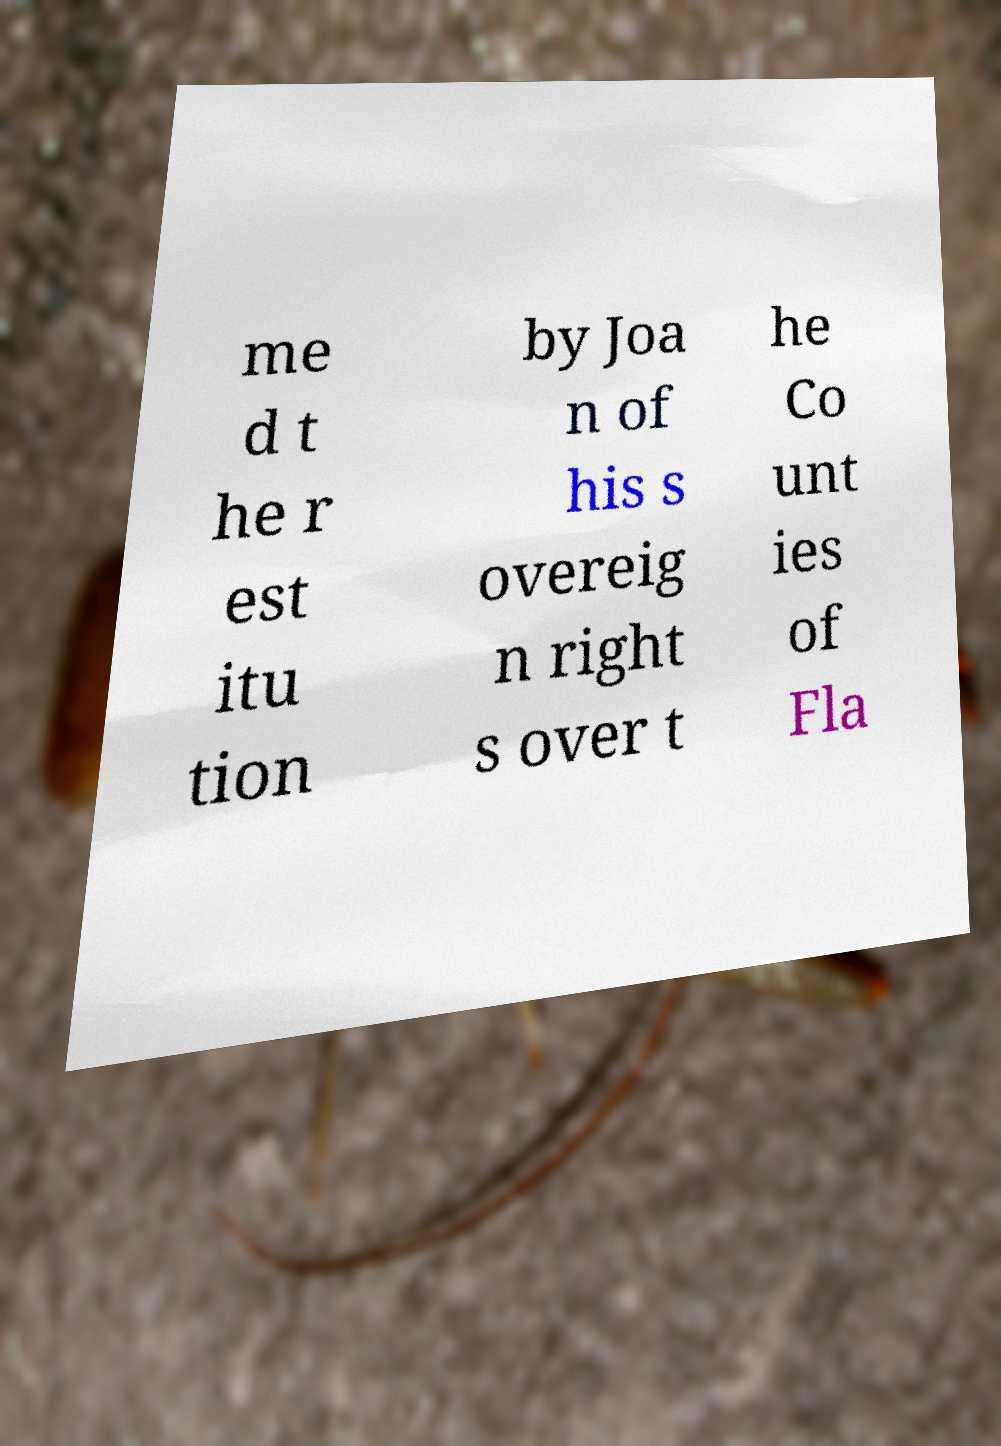For documentation purposes, I need the text within this image transcribed. Could you provide that? me d t he r est itu tion by Joa n of his s overeig n right s over t he Co unt ies of Fla 